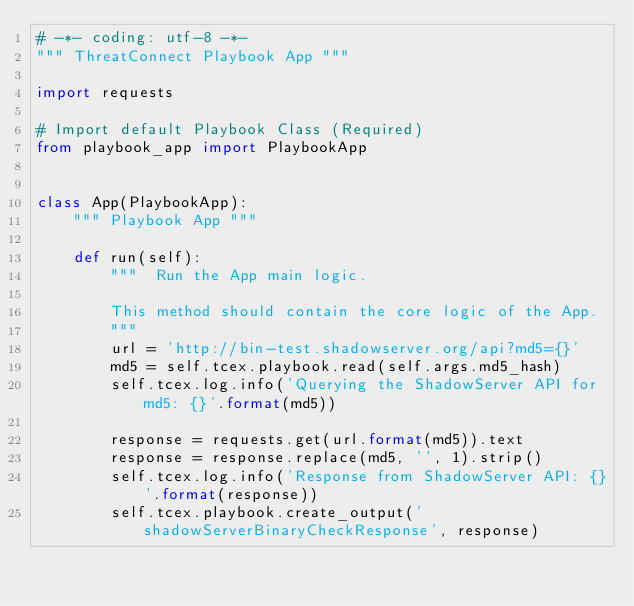Convert code to text. <code><loc_0><loc_0><loc_500><loc_500><_Python_># -*- coding: utf-8 -*-
""" ThreatConnect Playbook App """

import requests

# Import default Playbook Class (Required)
from playbook_app import PlaybookApp


class App(PlaybookApp):
    """ Playbook App """

    def run(self):
        """  Run the App main logic.

        This method should contain the core logic of the App.
        """
        url = 'http://bin-test.shadowserver.org/api?md5={}'
        md5 = self.tcex.playbook.read(self.args.md5_hash)
        self.tcex.log.info('Querying the ShadowServer API for md5: {}'.format(md5))

        response = requests.get(url.format(md5)).text
        response = response.replace(md5, '', 1).strip()
        self.tcex.log.info('Response from ShadowServer API: {}'.format(response))
        self.tcex.playbook.create_output('shadowServerBinaryCheckResponse', response)
</code> 